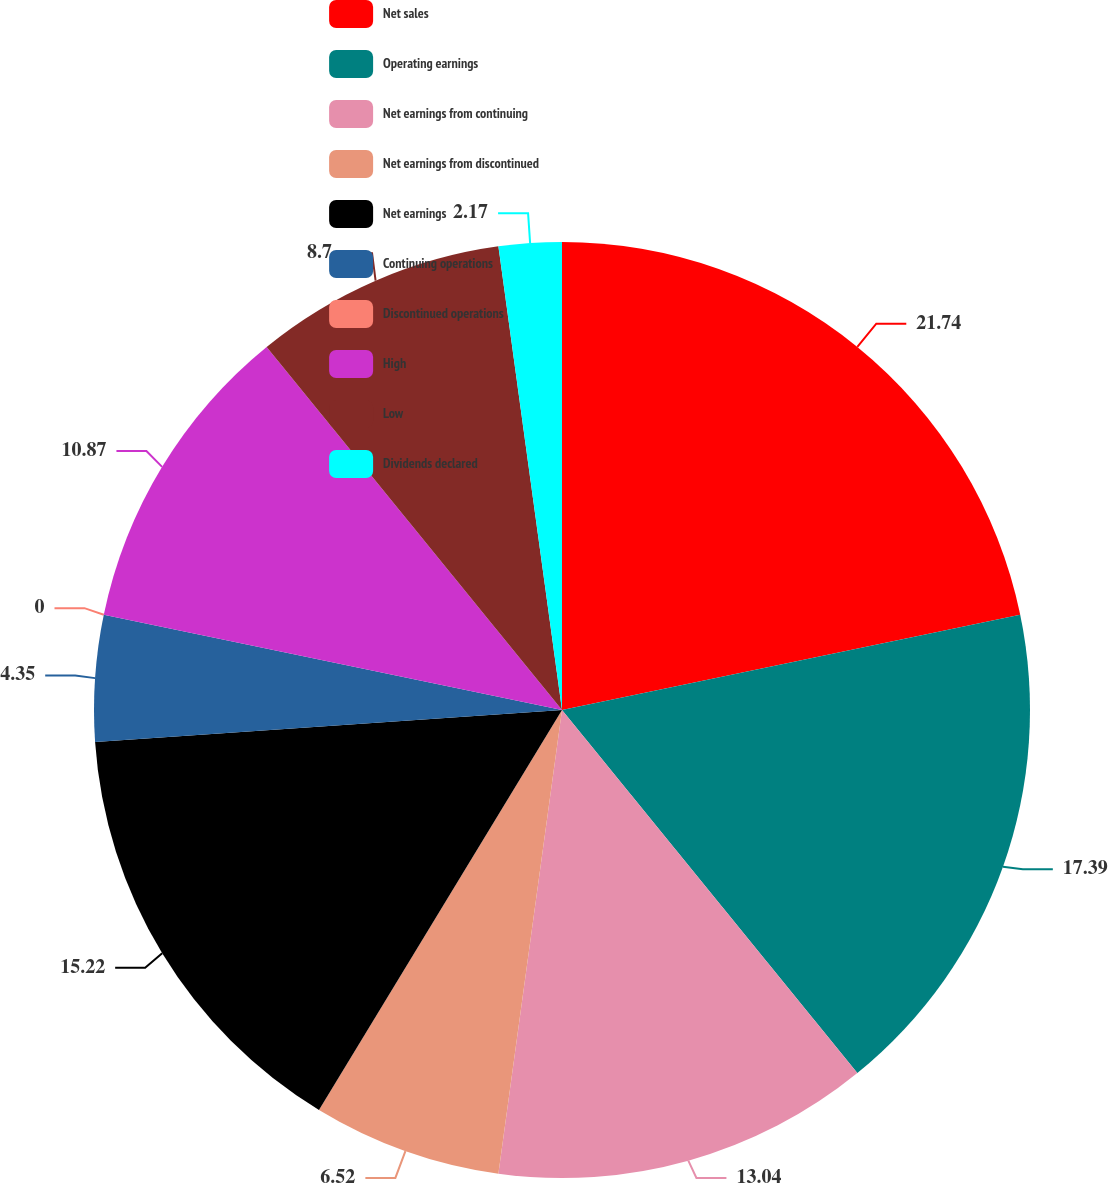<chart> <loc_0><loc_0><loc_500><loc_500><pie_chart><fcel>Net sales<fcel>Operating earnings<fcel>Net earnings from continuing<fcel>Net earnings from discontinued<fcel>Net earnings<fcel>Continuing operations<fcel>Discontinued operations<fcel>High<fcel>Low<fcel>Dividends declared<nl><fcel>21.74%<fcel>17.39%<fcel>13.04%<fcel>6.52%<fcel>15.22%<fcel>4.35%<fcel>0.0%<fcel>10.87%<fcel>8.7%<fcel>2.17%<nl></chart> 